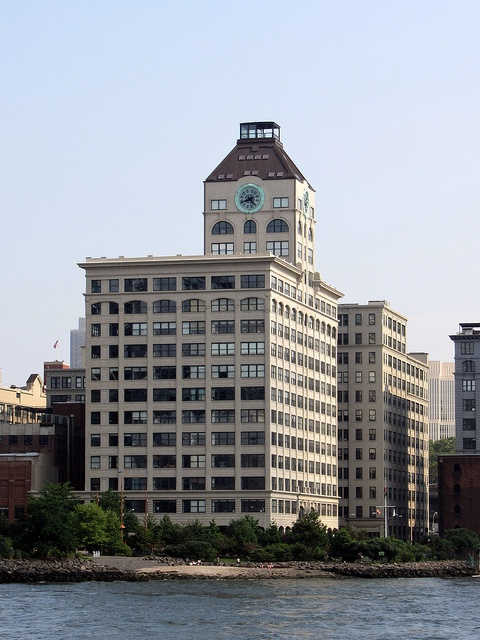Describe the objects in this image and their specific colors. I can see a clock in lavender, gray, darkgray, and blue tones in this image. 